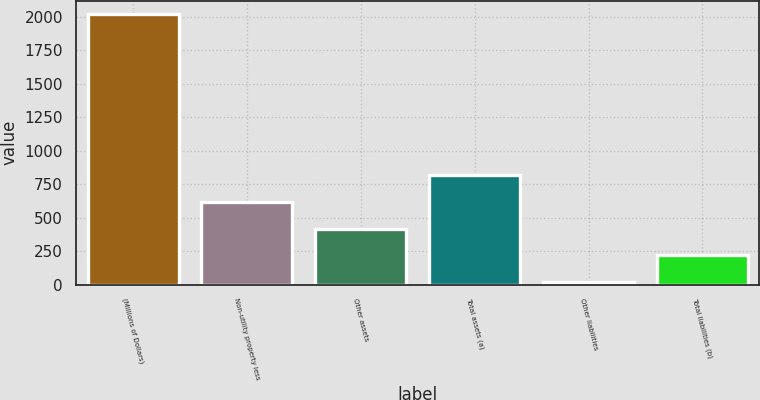Convert chart. <chart><loc_0><loc_0><loc_500><loc_500><bar_chart><fcel>(Millions of Dollars)<fcel>Non-utility property less<fcel>Other assets<fcel>Total assets (a)<fcel>Other liabilities<fcel>Total liabilities (b)<nl><fcel>2018<fcel>617.3<fcel>417.2<fcel>817.4<fcel>17<fcel>217.1<nl></chart> 